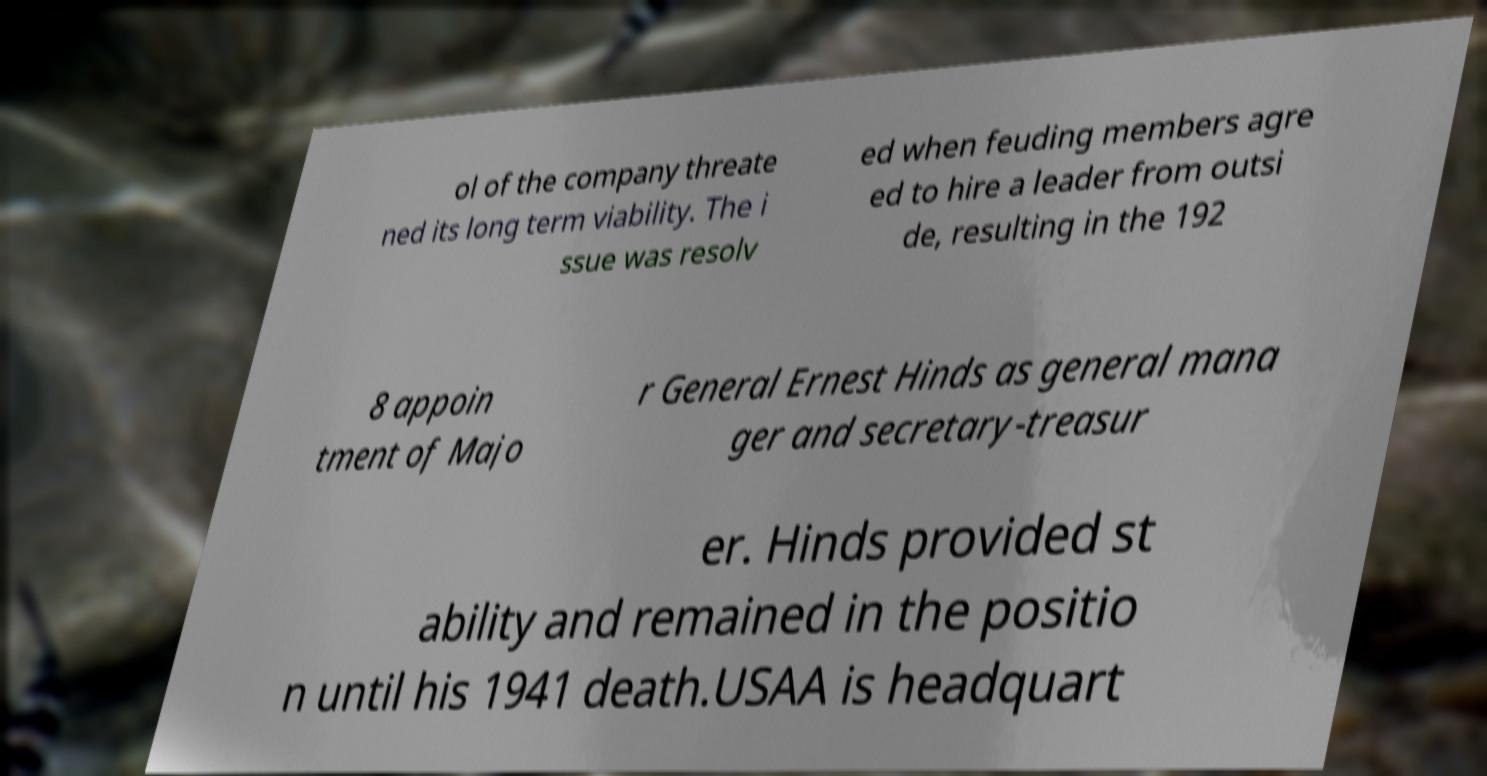Could you extract and type out the text from this image? ol of the company threate ned its long term viability. The i ssue was resolv ed when feuding members agre ed to hire a leader from outsi de, resulting in the 192 8 appoin tment of Majo r General Ernest Hinds as general mana ger and secretary-treasur er. Hinds provided st ability and remained in the positio n until his 1941 death.USAA is headquart 